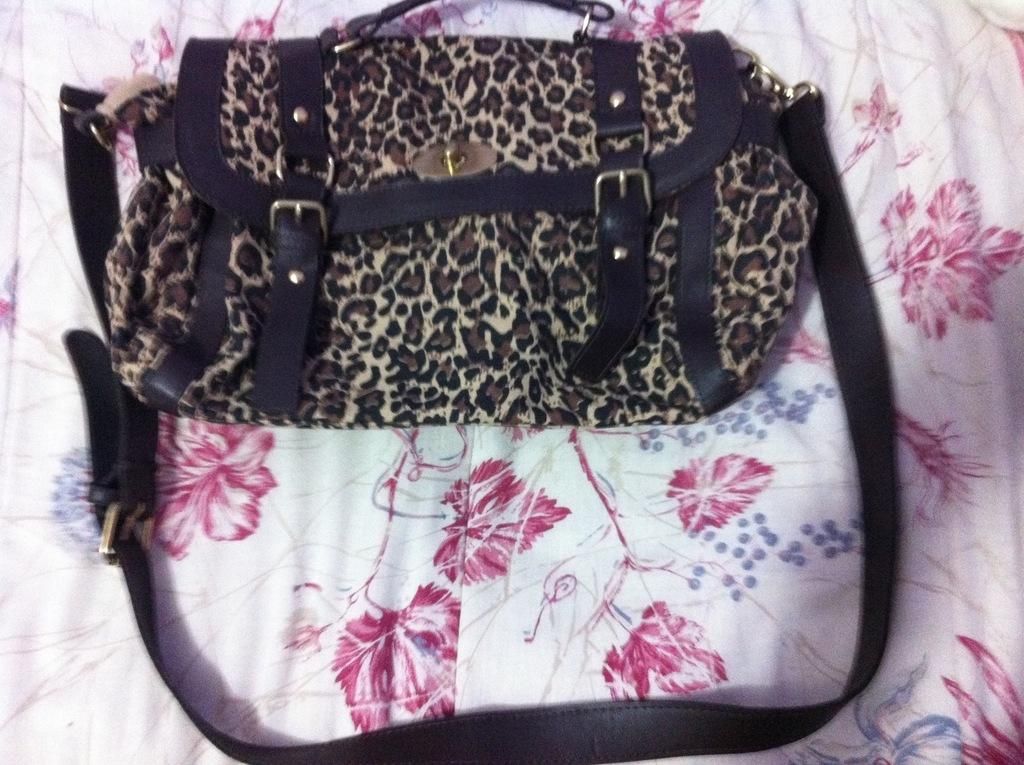What object is present in the image that can be used to carry items? There is a bag in the image that can be used to carry items. How is the bag designed to be carried? The bag has two straps, which suggests it can be carried on the shoulder or by hand. What is the bag placed on in the image? The bag is placed on a cloth in the image. Is there any poison visible in the image? No, there is no poison present in the image. Can you see a blade in the image? No, there is no blade present in the image. 